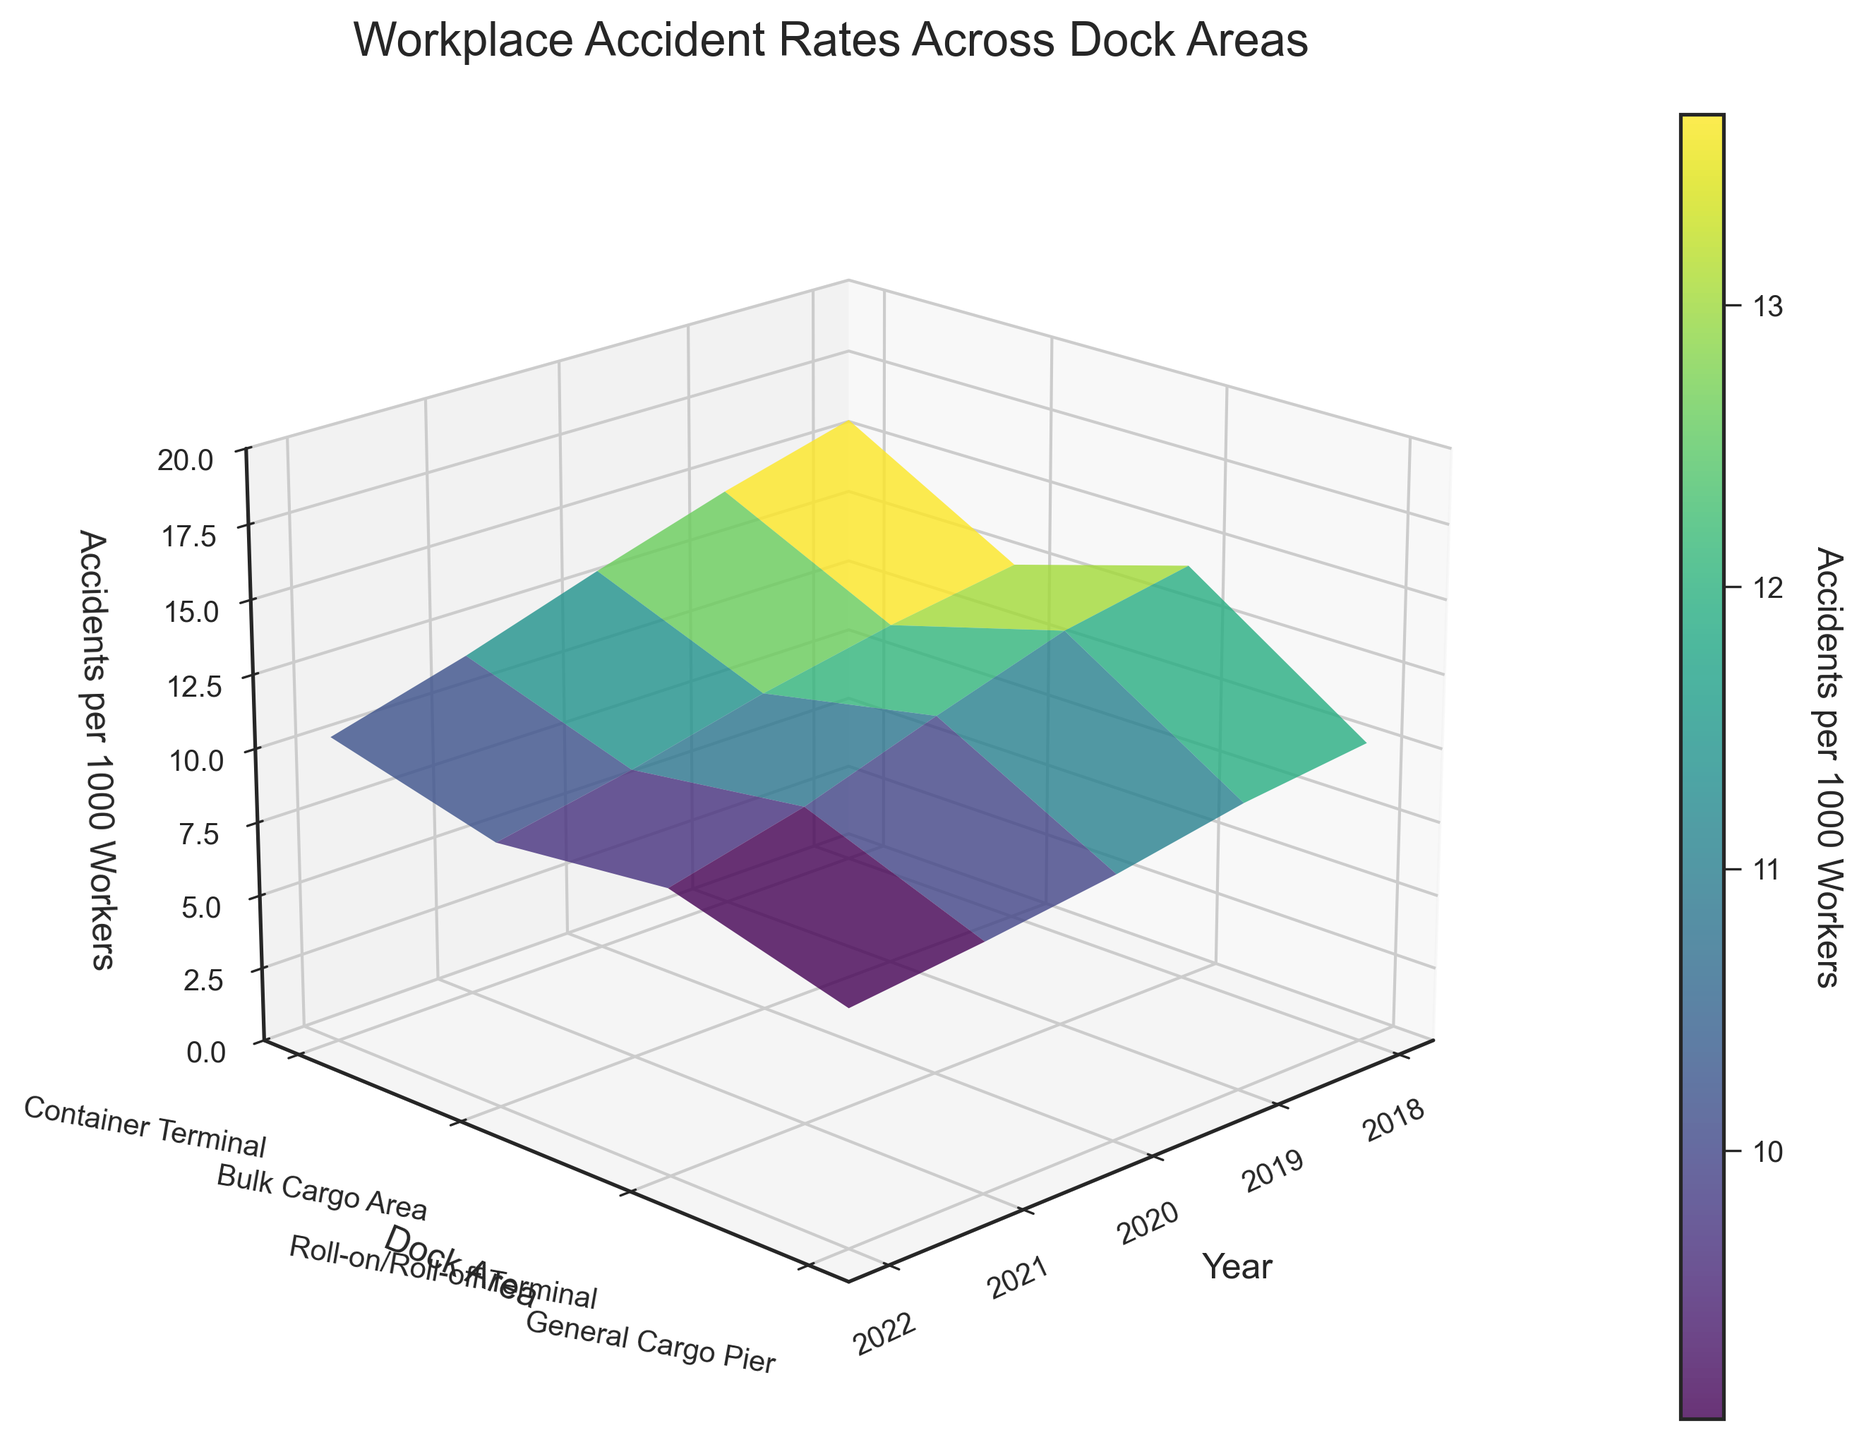what is the trend for accident rates in the Container Terminal from 2018 to 2022? By observing the Z-axis values for the Container Terminal over the years (X-axis), we can see the plot surface tilts downward. Specifically, accident rates decrease from 12.5 in 2018 to 8.9 in 2022.
Answer: Decreasing Which dock area had the highest accident rate in 2019? We look at the values along the Y-axis (dock areas) for the year 2019 and see which has the tallest Z value. In 2019, the highest accident rate is in the Bulk Cargo Area, with a rate of 14.6 accidents per 1000 workers.
Answer: Bulk Cargo Area In which year did the General Cargo Pier have the lowest accident rate? By examining the Z-axis values for the General Cargo Pier across different years, the lowest value appears in 2022 with 9.5 accidents per 1000 workers.
Answer: 2022 Compare the trend of accident rates between the Bulk Cargo Area and Roll-on/Roll-off Terminal from 2018 to 2022. Observing the plots, the Bulk Cargo Area shows a steep decline from 15.8 in 2018 to 10.4 in 2022. The Roll-on/Roll-off Terminal also declines but less dramatically, from 10.2 in 2018 to 7.8 in 2022.
Answer: Both declining, Bulk Cargo Area declines more What is the overall trend observed for workplace accident rates across all dock areas from 2018 to 2022? Looking at the surface plot as a whole, all areas tend to show a downward trend, indicating a general reduction in workplace accident rates over the years.
Answer: Decreasing How does the accident rate trend in the General Cargo Pier compare to the Container Terminal from 2018 to 2022? General Cargo Pier starts from 14.3 and decreases to 9.5, while the Container Terminal starts from 12.5 and decreases to 8.9. Both exhibit a downward trend, but the General Cargo Pier has a larger decrease.
Answer: Both decreasing, General Cargo Pier decreases more Which year saw the highest variability in accident rates among all dock areas? Comparing the vertical height differences in each year, 2018 displays the highest variability with a range from 10.2 to 15.8 across the areas.
Answer: 2018 